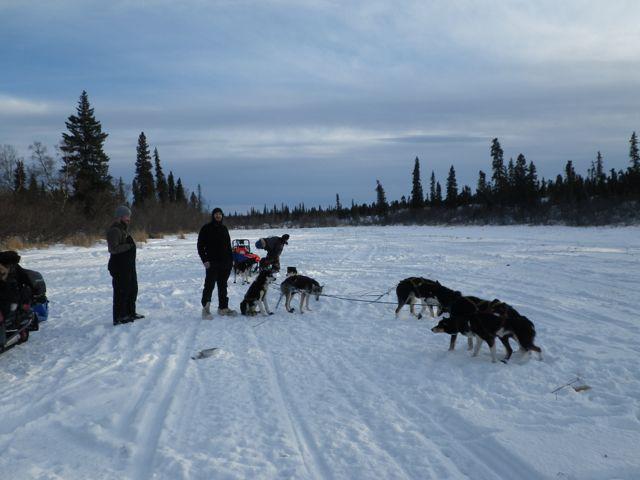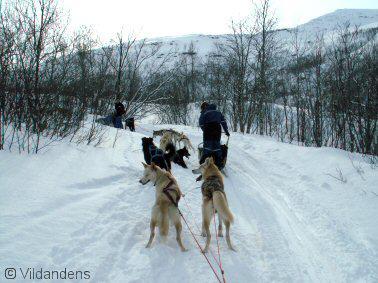The first image is the image on the left, the second image is the image on the right. For the images shown, is this caption "All the dogs are moving forward." true? Answer yes or no. No. The first image is the image on the left, the second image is the image on the right. Evaluate the accuracy of this statement regarding the images: "The dog team in the right image is moving away from the camera, and the dog team on the left is also moving, but not away from the camera.". Is it true? Answer yes or no. No. 